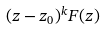<formula> <loc_0><loc_0><loc_500><loc_500>( z - z _ { 0 } ) ^ { k } F ( z )</formula> 